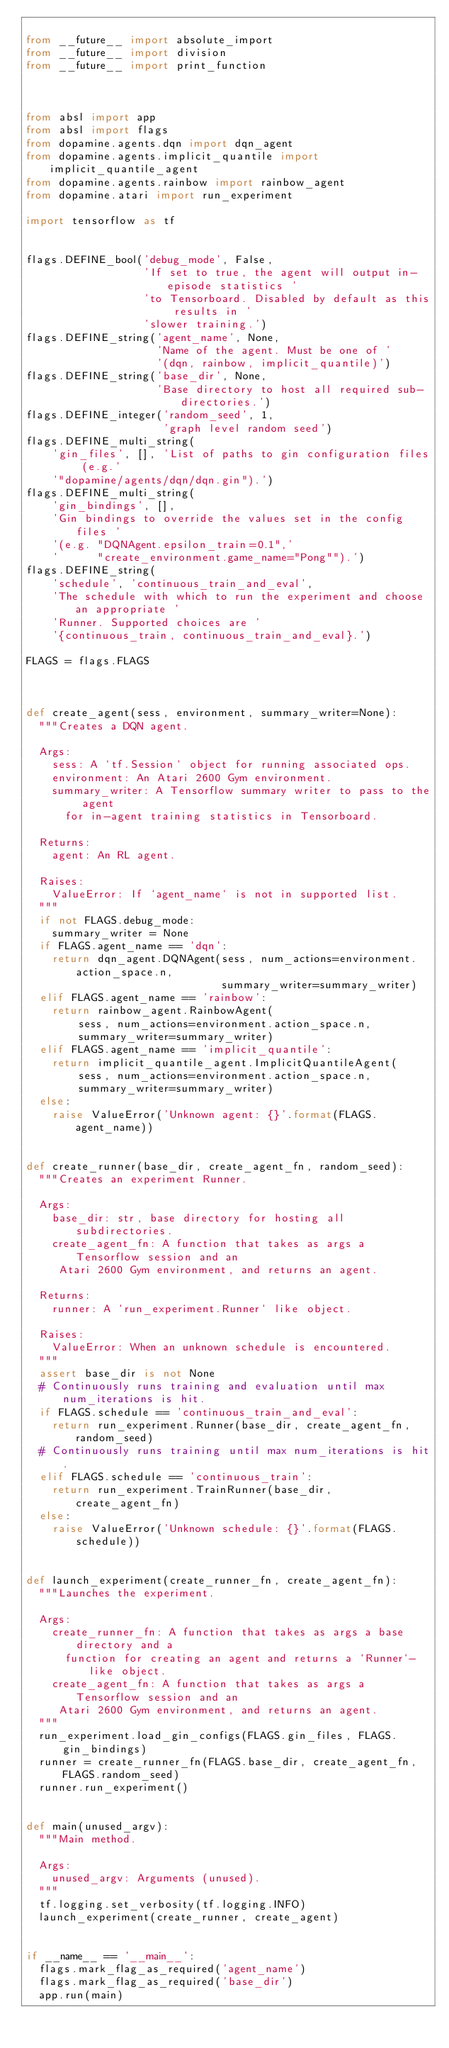Convert code to text. <code><loc_0><loc_0><loc_500><loc_500><_Python_>
from __future__ import absolute_import
from __future__ import division
from __future__ import print_function



from absl import app
from absl import flags
from dopamine.agents.dqn import dqn_agent
from dopamine.agents.implicit_quantile import implicit_quantile_agent
from dopamine.agents.rainbow import rainbow_agent
from dopamine.atari import run_experiment

import tensorflow as tf


flags.DEFINE_bool('debug_mode', False,
                  'If set to true, the agent will output in-episode statistics '
                  'to Tensorboard. Disabled by default as this results in '
                  'slower training.')
flags.DEFINE_string('agent_name', None,
                    'Name of the agent. Must be one of '
                    '(dqn, rainbow, implicit_quantile)')
flags.DEFINE_string('base_dir', None,
                    'Base directory to host all required sub-directories.')
flags.DEFINE_integer('random_seed', 1,
                     'graph level random seed')
flags.DEFINE_multi_string(
    'gin_files', [], 'List of paths to gin configuration files (e.g.'
    '"dopamine/agents/dqn/dqn.gin").')
flags.DEFINE_multi_string(
    'gin_bindings', [],
    'Gin bindings to override the values set in the config files '
    '(e.g. "DQNAgent.epsilon_train=0.1",'
    '      "create_environment.game_name="Pong"").')
flags.DEFINE_string(
    'schedule', 'continuous_train_and_eval',
    'The schedule with which to run the experiment and choose an appropriate '
    'Runner. Supported choices are '
    '{continuous_train, continuous_train_and_eval}.')

FLAGS = flags.FLAGS



def create_agent(sess, environment, summary_writer=None):
  """Creates a DQN agent.

  Args:
    sess: A `tf.Session` object for running associated ops.
    environment: An Atari 2600 Gym environment.
    summary_writer: A Tensorflow summary writer to pass to the agent
      for in-agent training statistics in Tensorboard.

  Returns:
    agent: An RL agent.

  Raises:
    ValueError: If `agent_name` is not in supported list.
  """
  if not FLAGS.debug_mode:
    summary_writer = None
  if FLAGS.agent_name == 'dqn':
    return dqn_agent.DQNAgent(sess, num_actions=environment.action_space.n,
                              summary_writer=summary_writer)
  elif FLAGS.agent_name == 'rainbow':
    return rainbow_agent.RainbowAgent(
        sess, num_actions=environment.action_space.n,
        summary_writer=summary_writer)
  elif FLAGS.agent_name == 'implicit_quantile':
    return implicit_quantile_agent.ImplicitQuantileAgent(
        sess, num_actions=environment.action_space.n,
        summary_writer=summary_writer)
  else:
    raise ValueError('Unknown agent: {}'.format(FLAGS.agent_name))


def create_runner(base_dir, create_agent_fn, random_seed):
  """Creates an experiment Runner.

  Args:
    base_dir: str, base directory for hosting all subdirectories.
    create_agent_fn: A function that takes as args a Tensorflow session and an
     Atari 2600 Gym environment, and returns an agent.

  Returns:
    runner: A `run_experiment.Runner` like object.

  Raises:
    ValueError: When an unknown schedule is encountered.
  """
  assert base_dir is not None
  # Continuously runs training and evaluation until max num_iterations is hit.
  if FLAGS.schedule == 'continuous_train_and_eval':
    return run_experiment.Runner(base_dir, create_agent_fn, random_seed)
  # Continuously runs training until max num_iterations is hit.
  elif FLAGS.schedule == 'continuous_train':
    return run_experiment.TrainRunner(base_dir, create_agent_fn)
  else:
    raise ValueError('Unknown schedule: {}'.format(FLAGS.schedule))


def launch_experiment(create_runner_fn, create_agent_fn):
  """Launches the experiment.

  Args:
    create_runner_fn: A function that takes as args a base directory and a
      function for creating an agent and returns a `Runner`-like object.
    create_agent_fn: A function that takes as args a Tensorflow session and an
     Atari 2600 Gym environment, and returns an agent.
  """
  run_experiment.load_gin_configs(FLAGS.gin_files, FLAGS.gin_bindings)
  runner = create_runner_fn(FLAGS.base_dir, create_agent_fn, FLAGS.random_seed)
  runner.run_experiment()


def main(unused_argv):
  """Main method.

  Args:
    unused_argv: Arguments (unused).
  """
  tf.logging.set_verbosity(tf.logging.INFO)
  launch_experiment(create_runner, create_agent)


if __name__ == '__main__':
  flags.mark_flag_as_required('agent_name')
  flags.mark_flag_as_required('base_dir')
  app.run(main)
</code> 